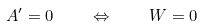Convert formula to latex. <formula><loc_0><loc_0><loc_500><loc_500>A ^ { \prime } = 0 \quad \Leftrightarrow \quad W = 0</formula> 